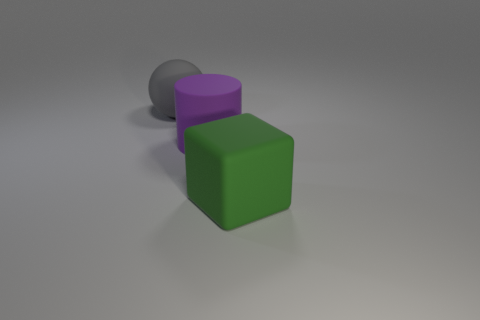Are there fewer big purple objects than cyan blocks?
Your answer should be very brief. No. There is a large rubber object behind the big purple cylinder; does it have the same color as the large cube?
Provide a short and direct response. No. What number of purple cylinders are the same size as the matte sphere?
Offer a terse response. 1. Is there a large matte sphere of the same color as the big rubber cube?
Give a very brief answer. No. Is the big green thing made of the same material as the large cylinder?
Give a very brief answer. Yes. How many green matte objects are the same shape as the large gray rubber thing?
Offer a very short reply. 0. There is a large green object that is made of the same material as the gray ball; what shape is it?
Keep it short and to the point. Cube. Does the big rubber ball have the same color as the big matte cylinder?
Keep it short and to the point. No. What number of matte things are left of the big rubber cube and in front of the big gray rubber sphere?
Offer a very short reply. 1. What is the shape of the gray matte object?
Offer a terse response. Sphere. 